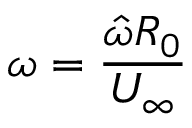<formula> <loc_0><loc_0><loc_500><loc_500>\omega = \frac { \hat { \omega } R _ { 0 } } { U _ { \infty } }</formula> 